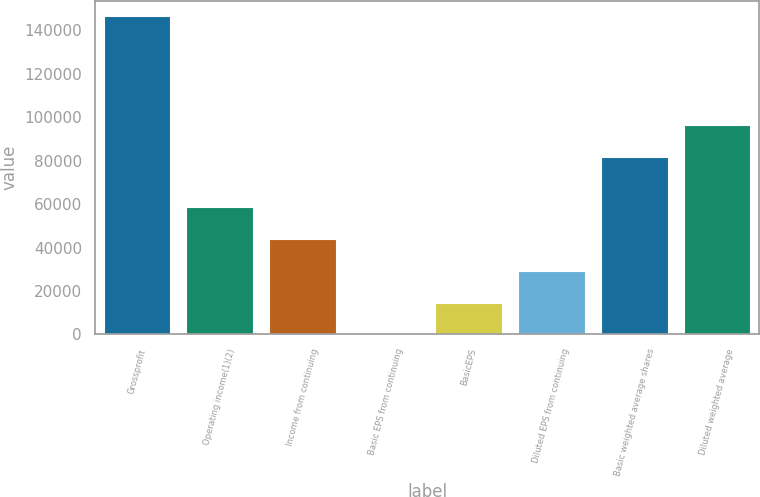<chart> <loc_0><loc_0><loc_500><loc_500><bar_chart><fcel>Grossprofit<fcel>Operating income(1)(2)<fcel>Income from continuing<fcel>Basic EPS from continuing<fcel>BasicEPS<fcel>Diluted EPS from continuing<fcel>Basic weighted average shares<fcel>Diluted weighted average<nl><fcel>146397<fcel>58558.9<fcel>43919.3<fcel>0.23<fcel>14639.9<fcel>29279.6<fcel>81572<fcel>96211.7<nl></chart> 